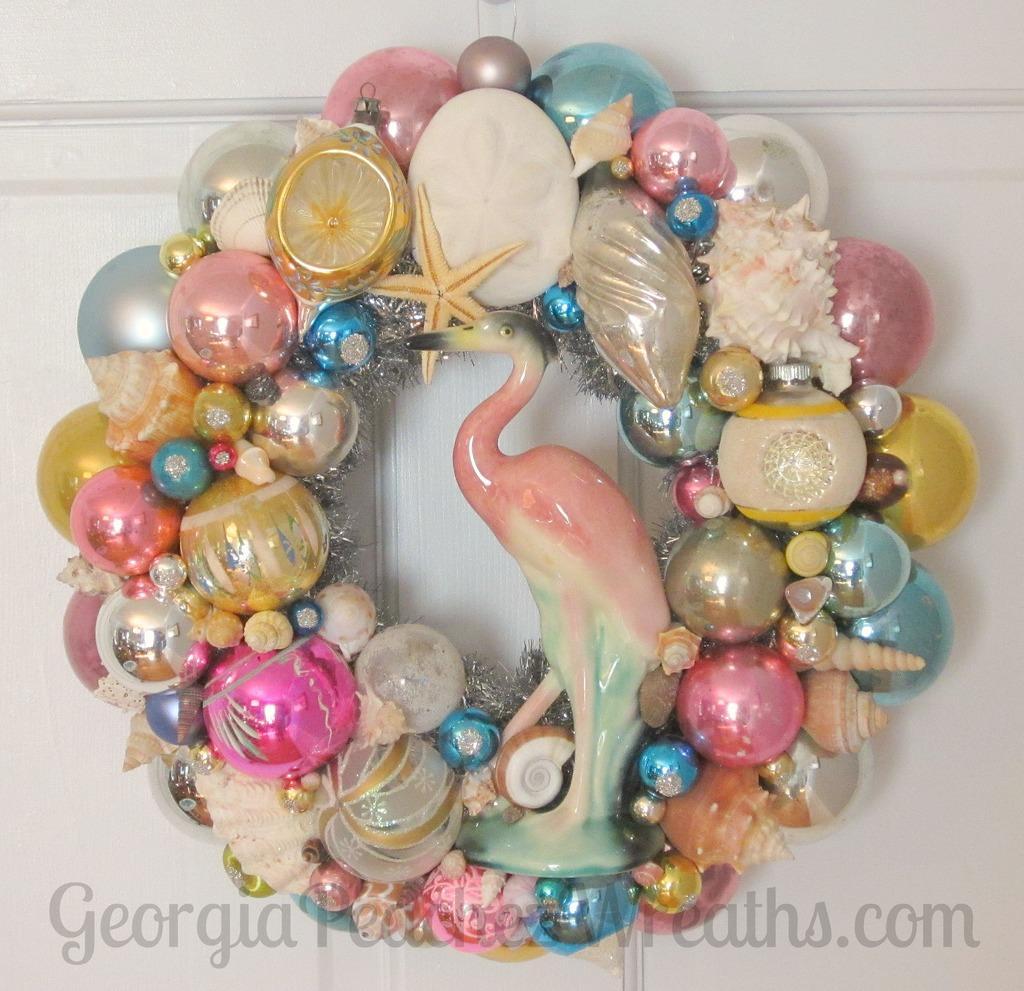In one or two sentences, can you explain what this image depicts? In this picture I can see some objects are attached to a white color wall. Here I can see a watermark. 